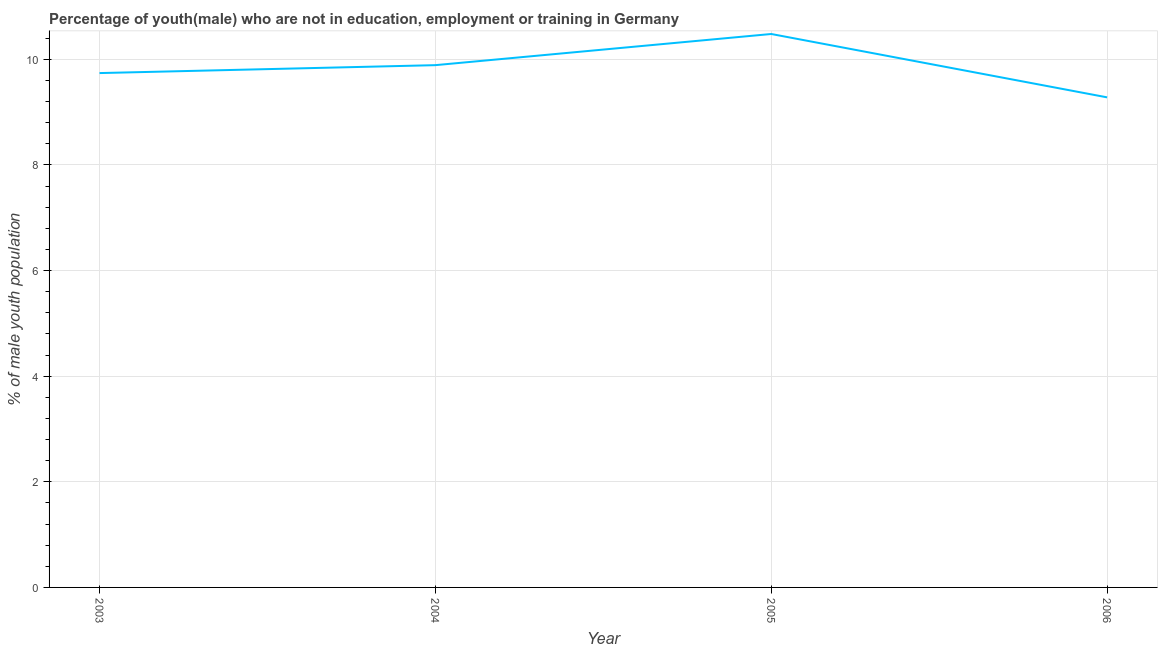What is the unemployed male youth population in 2004?
Your answer should be very brief. 9.89. Across all years, what is the maximum unemployed male youth population?
Your response must be concise. 10.48. Across all years, what is the minimum unemployed male youth population?
Provide a succinct answer. 9.28. In which year was the unemployed male youth population maximum?
Your answer should be very brief. 2005. In which year was the unemployed male youth population minimum?
Provide a succinct answer. 2006. What is the sum of the unemployed male youth population?
Provide a succinct answer. 39.39. What is the difference between the unemployed male youth population in 2004 and 2005?
Keep it short and to the point. -0.59. What is the average unemployed male youth population per year?
Your answer should be compact. 9.85. What is the median unemployed male youth population?
Your answer should be compact. 9.82. What is the ratio of the unemployed male youth population in 2004 to that in 2005?
Offer a very short reply. 0.94. What is the difference between the highest and the second highest unemployed male youth population?
Provide a succinct answer. 0.59. Is the sum of the unemployed male youth population in 2003 and 2005 greater than the maximum unemployed male youth population across all years?
Provide a short and direct response. Yes. What is the difference between the highest and the lowest unemployed male youth population?
Your answer should be very brief. 1.2. In how many years, is the unemployed male youth population greater than the average unemployed male youth population taken over all years?
Give a very brief answer. 2. Does the unemployed male youth population monotonically increase over the years?
Your answer should be compact. No. How many years are there in the graph?
Your answer should be very brief. 4. Are the values on the major ticks of Y-axis written in scientific E-notation?
Your answer should be very brief. No. What is the title of the graph?
Make the answer very short. Percentage of youth(male) who are not in education, employment or training in Germany. What is the label or title of the Y-axis?
Keep it short and to the point. % of male youth population. What is the % of male youth population in 2003?
Give a very brief answer. 9.74. What is the % of male youth population in 2004?
Offer a very short reply. 9.89. What is the % of male youth population of 2005?
Keep it short and to the point. 10.48. What is the % of male youth population of 2006?
Your answer should be very brief. 9.28. What is the difference between the % of male youth population in 2003 and 2005?
Offer a very short reply. -0.74. What is the difference between the % of male youth population in 2003 and 2006?
Make the answer very short. 0.46. What is the difference between the % of male youth population in 2004 and 2005?
Offer a very short reply. -0.59. What is the difference between the % of male youth population in 2004 and 2006?
Make the answer very short. 0.61. What is the difference between the % of male youth population in 2005 and 2006?
Your answer should be compact. 1.2. What is the ratio of the % of male youth population in 2003 to that in 2004?
Provide a succinct answer. 0.98. What is the ratio of the % of male youth population in 2003 to that in 2005?
Keep it short and to the point. 0.93. What is the ratio of the % of male youth population in 2004 to that in 2005?
Make the answer very short. 0.94. What is the ratio of the % of male youth population in 2004 to that in 2006?
Provide a short and direct response. 1.07. What is the ratio of the % of male youth population in 2005 to that in 2006?
Offer a very short reply. 1.13. 